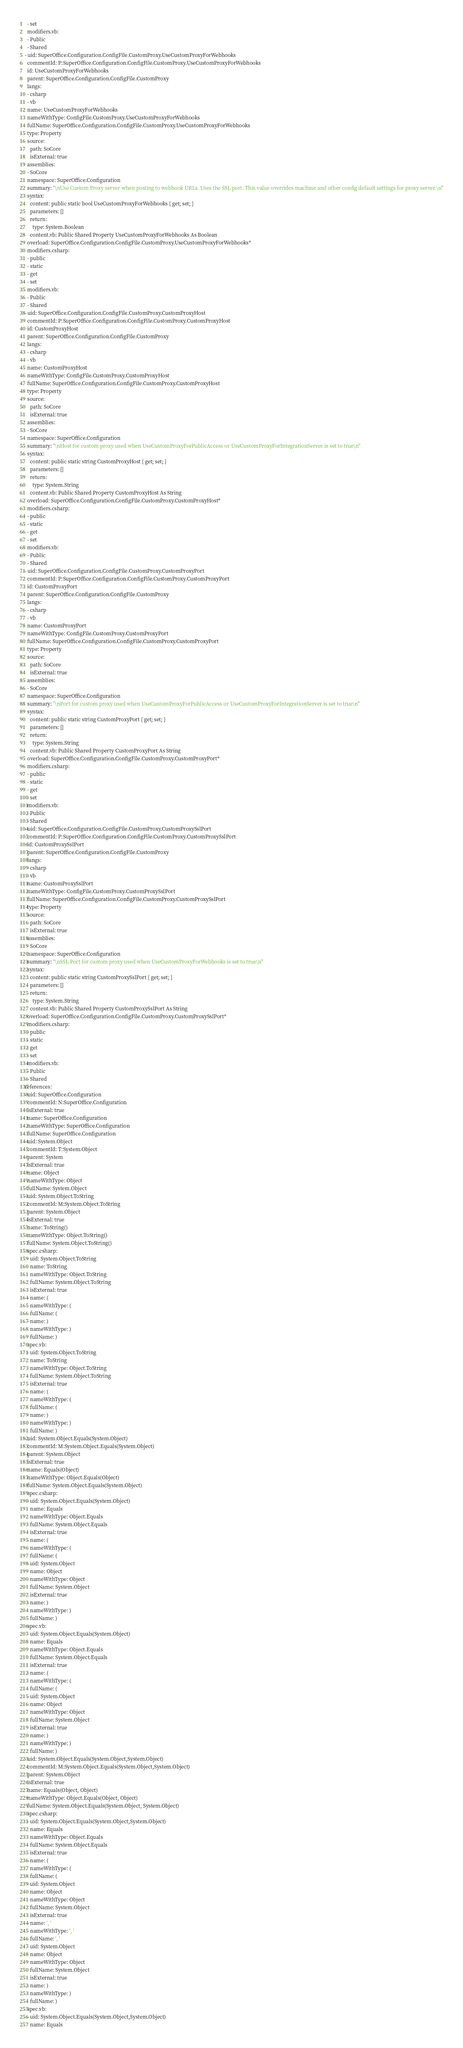<code> <loc_0><loc_0><loc_500><loc_500><_YAML_>  - set
  modifiers.vb:
  - Public
  - Shared
- uid: SuperOffice.Configuration.ConfigFile.CustomProxy.UseCustomProxyForWebhooks
  commentId: P:SuperOffice.Configuration.ConfigFile.CustomProxy.UseCustomProxyForWebhooks
  id: UseCustomProxyForWebhooks
  parent: SuperOffice.Configuration.ConfigFile.CustomProxy
  langs:
  - csharp
  - vb
  name: UseCustomProxyForWebhooks
  nameWithType: ConfigFile.CustomProxy.UseCustomProxyForWebhooks
  fullName: SuperOffice.Configuration.ConfigFile.CustomProxy.UseCustomProxyForWebhooks
  type: Property
  source:
    path: SoCore
    isExternal: true
  assemblies:
  - SoCore
  namespace: SuperOffice.Configuration
  summary: "\nUse Custom Proxy server when posting to webhook URLs. Uses the SSL port. This value overrides machine and other config default settings for proxy server.\n"
  syntax:
    content: public static bool UseCustomProxyForWebhooks { get; set; }
    parameters: []
    return:
      type: System.Boolean
    content.vb: Public Shared Property UseCustomProxyForWebhooks As Boolean
  overload: SuperOffice.Configuration.ConfigFile.CustomProxy.UseCustomProxyForWebhooks*
  modifiers.csharp:
  - public
  - static
  - get
  - set
  modifiers.vb:
  - Public
  - Shared
- uid: SuperOffice.Configuration.ConfigFile.CustomProxy.CustomProxyHost
  commentId: P:SuperOffice.Configuration.ConfigFile.CustomProxy.CustomProxyHost
  id: CustomProxyHost
  parent: SuperOffice.Configuration.ConfigFile.CustomProxy
  langs:
  - csharp
  - vb
  name: CustomProxyHost
  nameWithType: ConfigFile.CustomProxy.CustomProxyHost
  fullName: SuperOffice.Configuration.ConfigFile.CustomProxy.CustomProxyHost
  type: Property
  source:
    path: SoCore
    isExternal: true
  assemblies:
  - SoCore
  namespace: SuperOffice.Configuration
  summary: "\nHost for custom proxy used when UseCustomProxyForPublicAccess or UseCustomProxyForIntegrationServer is set to true\n"
  syntax:
    content: public static string CustomProxyHost { get; set; }
    parameters: []
    return:
      type: System.String
    content.vb: Public Shared Property CustomProxyHost As String
  overload: SuperOffice.Configuration.ConfigFile.CustomProxy.CustomProxyHost*
  modifiers.csharp:
  - public
  - static
  - get
  - set
  modifiers.vb:
  - Public
  - Shared
- uid: SuperOffice.Configuration.ConfigFile.CustomProxy.CustomProxyPort
  commentId: P:SuperOffice.Configuration.ConfigFile.CustomProxy.CustomProxyPort
  id: CustomProxyPort
  parent: SuperOffice.Configuration.ConfigFile.CustomProxy
  langs:
  - csharp
  - vb
  name: CustomProxyPort
  nameWithType: ConfigFile.CustomProxy.CustomProxyPort
  fullName: SuperOffice.Configuration.ConfigFile.CustomProxy.CustomProxyPort
  type: Property
  source:
    path: SoCore
    isExternal: true
  assemblies:
  - SoCore
  namespace: SuperOffice.Configuration
  summary: "\nPort for custom proxy used when UseCustomProxyForPublicAccess or UseCustomProxyForIntegrationServer is set to true\n"
  syntax:
    content: public static string CustomProxyPort { get; set; }
    parameters: []
    return:
      type: System.String
    content.vb: Public Shared Property CustomProxyPort As String
  overload: SuperOffice.Configuration.ConfigFile.CustomProxy.CustomProxyPort*
  modifiers.csharp:
  - public
  - static
  - get
  - set
  modifiers.vb:
  - Public
  - Shared
- uid: SuperOffice.Configuration.ConfigFile.CustomProxy.CustomProxySslPort
  commentId: P:SuperOffice.Configuration.ConfigFile.CustomProxy.CustomProxySslPort
  id: CustomProxySslPort
  parent: SuperOffice.Configuration.ConfigFile.CustomProxy
  langs:
  - csharp
  - vb
  name: CustomProxySslPort
  nameWithType: ConfigFile.CustomProxy.CustomProxySslPort
  fullName: SuperOffice.Configuration.ConfigFile.CustomProxy.CustomProxySslPort
  type: Property
  source:
    path: SoCore
    isExternal: true
  assemblies:
  - SoCore
  namespace: SuperOffice.Configuration
  summary: "\nSSL Port for custom proxy used when UseCustomProxyForWebhooks is set to true\n"
  syntax:
    content: public static string CustomProxySslPort { get; set; }
    parameters: []
    return:
      type: System.String
    content.vb: Public Shared Property CustomProxySslPort As String
  overload: SuperOffice.Configuration.ConfigFile.CustomProxy.CustomProxySslPort*
  modifiers.csharp:
  - public
  - static
  - get
  - set
  modifiers.vb:
  - Public
  - Shared
references:
- uid: SuperOffice.Configuration
  commentId: N:SuperOffice.Configuration
  isExternal: true
  name: SuperOffice.Configuration
  nameWithType: SuperOffice.Configuration
  fullName: SuperOffice.Configuration
- uid: System.Object
  commentId: T:System.Object
  parent: System
  isExternal: true
  name: Object
  nameWithType: Object
  fullName: System.Object
- uid: System.Object.ToString
  commentId: M:System.Object.ToString
  parent: System.Object
  isExternal: true
  name: ToString()
  nameWithType: Object.ToString()
  fullName: System.Object.ToString()
  spec.csharp:
  - uid: System.Object.ToString
    name: ToString
    nameWithType: Object.ToString
    fullName: System.Object.ToString
    isExternal: true
  - name: (
    nameWithType: (
    fullName: (
  - name: )
    nameWithType: )
    fullName: )
  spec.vb:
  - uid: System.Object.ToString
    name: ToString
    nameWithType: Object.ToString
    fullName: System.Object.ToString
    isExternal: true
  - name: (
    nameWithType: (
    fullName: (
  - name: )
    nameWithType: )
    fullName: )
- uid: System.Object.Equals(System.Object)
  commentId: M:System.Object.Equals(System.Object)
  parent: System.Object
  isExternal: true
  name: Equals(Object)
  nameWithType: Object.Equals(Object)
  fullName: System.Object.Equals(System.Object)
  spec.csharp:
  - uid: System.Object.Equals(System.Object)
    name: Equals
    nameWithType: Object.Equals
    fullName: System.Object.Equals
    isExternal: true
  - name: (
    nameWithType: (
    fullName: (
  - uid: System.Object
    name: Object
    nameWithType: Object
    fullName: System.Object
    isExternal: true
  - name: )
    nameWithType: )
    fullName: )
  spec.vb:
  - uid: System.Object.Equals(System.Object)
    name: Equals
    nameWithType: Object.Equals
    fullName: System.Object.Equals
    isExternal: true
  - name: (
    nameWithType: (
    fullName: (
  - uid: System.Object
    name: Object
    nameWithType: Object
    fullName: System.Object
    isExternal: true
  - name: )
    nameWithType: )
    fullName: )
- uid: System.Object.Equals(System.Object,System.Object)
  commentId: M:System.Object.Equals(System.Object,System.Object)
  parent: System.Object
  isExternal: true
  name: Equals(Object, Object)
  nameWithType: Object.Equals(Object, Object)
  fullName: System.Object.Equals(System.Object, System.Object)
  spec.csharp:
  - uid: System.Object.Equals(System.Object,System.Object)
    name: Equals
    nameWithType: Object.Equals
    fullName: System.Object.Equals
    isExternal: true
  - name: (
    nameWithType: (
    fullName: (
  - uid: System.Object
    name: Object
    nameWithType: Object
    fullName: System.Object
    isExternal: true
  - name: ', '
    nameWithType: ', '
    fullName: ', '
  - uid: System.Object
    name: Object
    nameWithType: Object
    fullName: System.Object
    isExternal: true
  - name: )
    nameWithType: )
    fullName: )
  spec.vb:
  - uid: System.Object.Equals(System.Object,System.Object)
    name: Equals</code> 